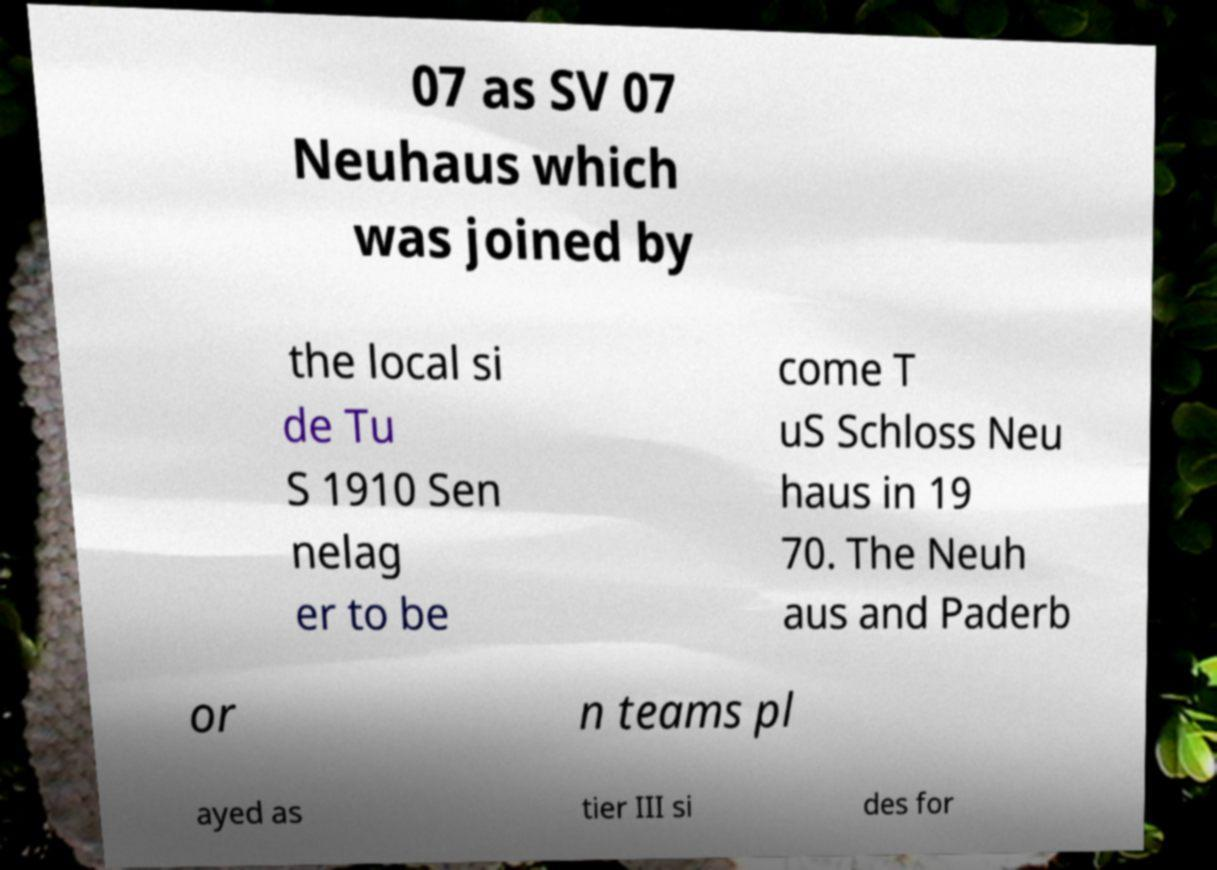For documentation purposes, I need the text within this image transcribed. Could you provide that? 07 as SV 07 Neuhaus which was joined by the local si de Tu S 1910 Sen nelag er to be come T uS Schloss Neu haus in 19 70. The Neuh aus and Paderb or n teams pl ayed as tier III si des for 